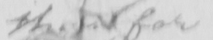Please transcribe the handwritten text in this image. by them 